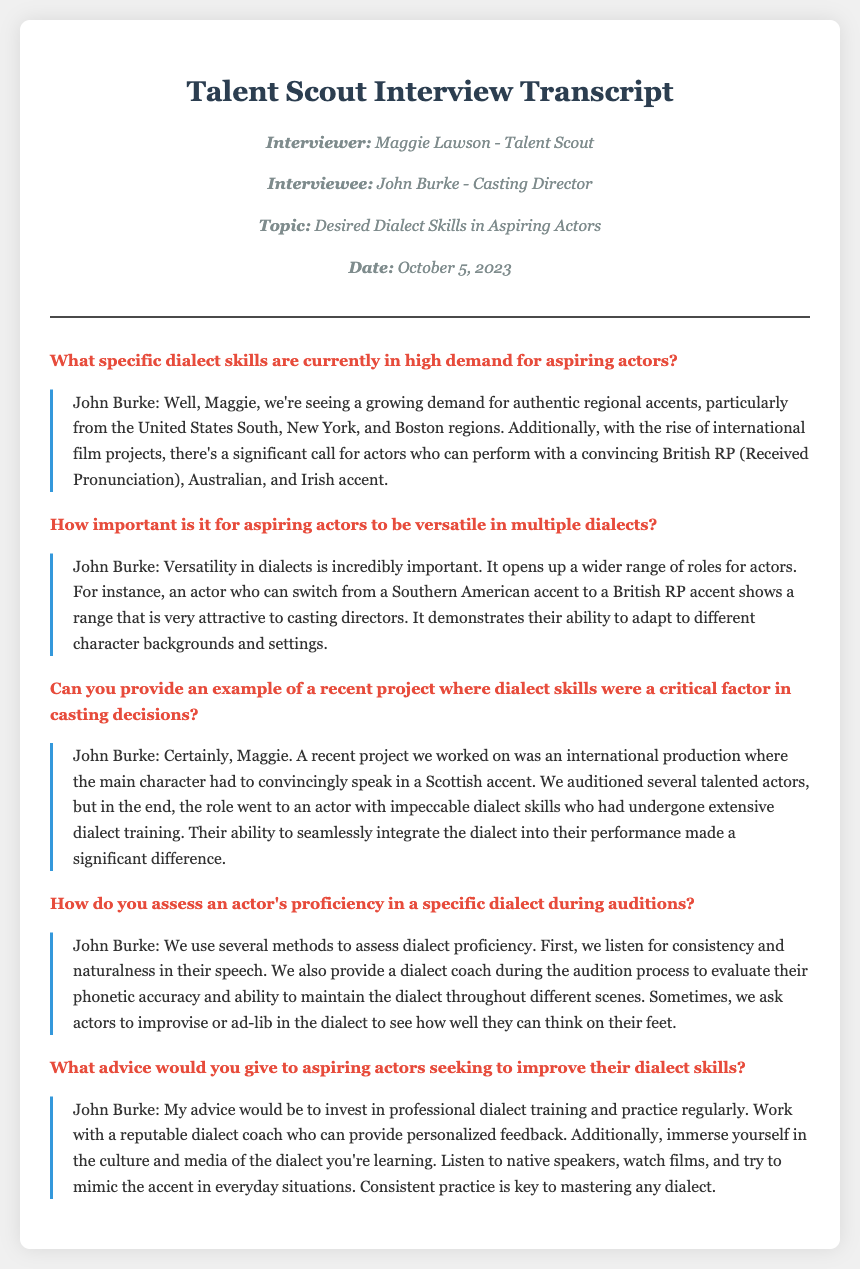What is the name of the interviewer? The interviewer's name is mentioned at the beginning of the document as Maggie Lawson.
Answer: Maggie Lawson What are three dialects in high demand for aspiring actors? The document lists several dialects, specifically mentioning Southern, British RP, and Australian accents.
Answer: Southern, British RP, Australian What is the date of the interview? The date of the interview is listed clearly in the header of the document as October 5, 2023.
Answer: October 5, 2023 How does John Burke describe the importance of dialect versatility? He explains how versatility in dialects opens up a wider range of roles for actors, indicating its significant attractiveness to casting directors.
Answer: Incredibly important What was a specific project mentioned where dialect skills were critical? The document notes an international production with a main character that needed to speak in a Scottish accent.
Answer: Scottish accent What method is used to assess dialect proficiency during auditions? The document states that a dialect coach is provided during auditions to evaluate phonetic accuracy and consistency.
Answer: Dialect coach What advice does John Burke give for practicing dialects? He advises investing in professional dialect training and regular practice with a reputable dialect coach.
Answer: Invest in professional dialect training What is one of the attributes a successful candidate showed in the audition? The candidate demonstrated the ability to seamlessly integrate the dialect into their performance.
Answer: Seamless integration 